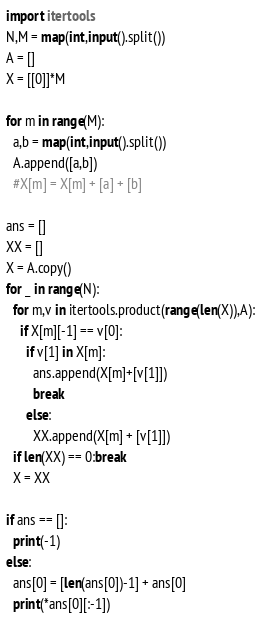<code> <loc_0><loc_0><loc_500><loc_500><_Python_>import itertools
N,M = map(int,input().split())
A = []
X = [[0]]*M

for m in range(M):
  a,b = map(int,input().split())
  A.append([a,b])
  #X[m] = X[m] + [a] + [b]

ans = []
XX = []
X = A.copy()
for _ in range(N):
  for m,v in itertools.product(range(len(X)),A):
    if X[m][-1] == v[0]:
      if v[1] in X[m]:
        ans.append(X[m]+[v[1]])
        break
      else:
        XX.append(X[m] + [v[1]])
  if len(XX) == 0:break
  X = XX

if ans == []:
  print(-1)
else:
  ans[0] = [len(ans[0])-1] + ans[0]
  print(*ans[0][:-1])
</code> 